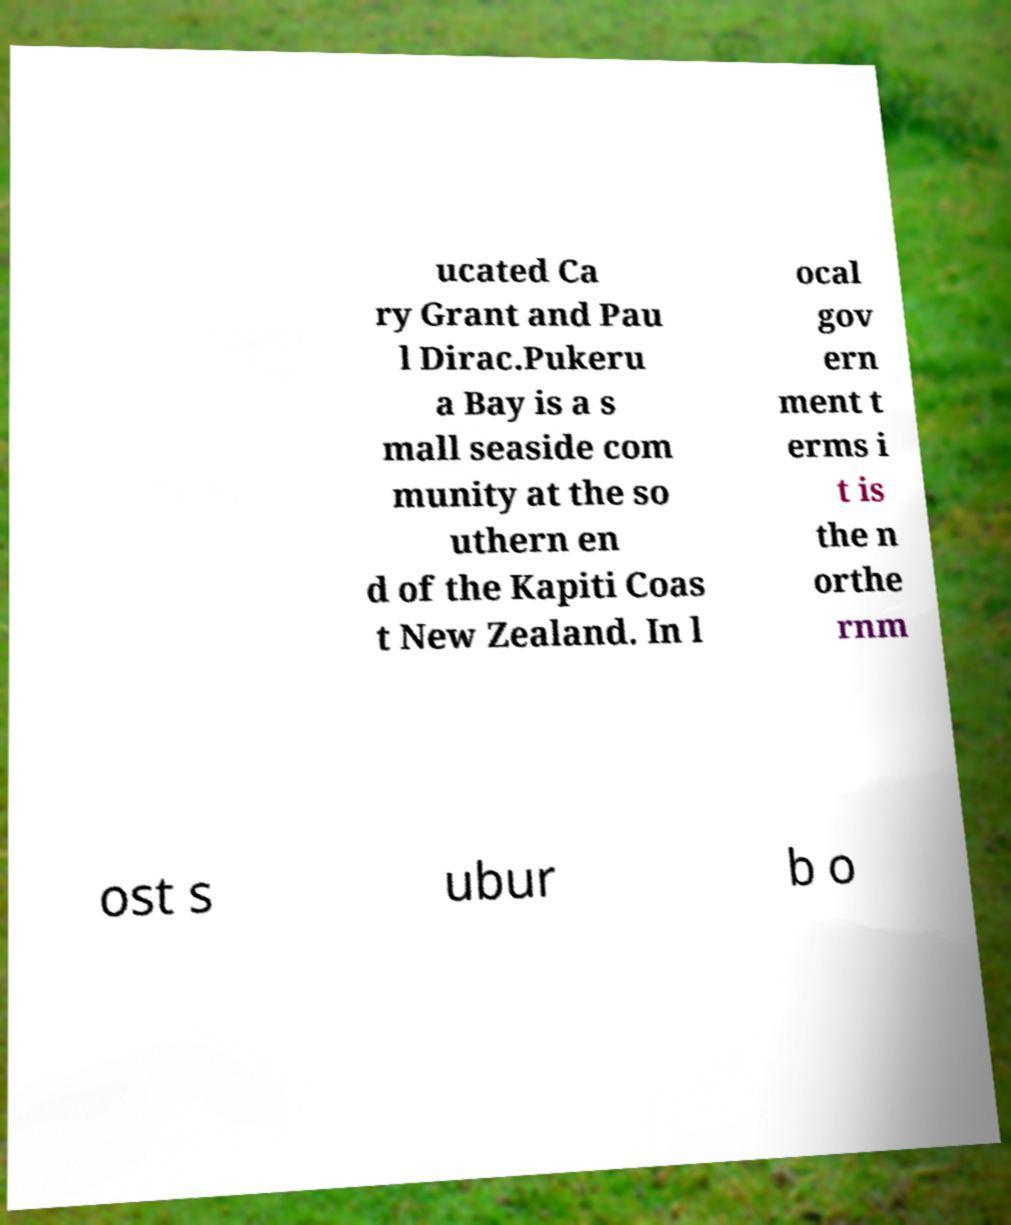What messages or text are displayed in this image? I need them in a readable, typed format. ucated Ca ry Grant and Pau l Dirac.Pukeru a Bay is a s mall seaside com munity at the so uthern en d of the Kapiti Coas t New Zealand. In l ocal gov ern ment t erms i t is the n orthe rnm ost s ubur b o 